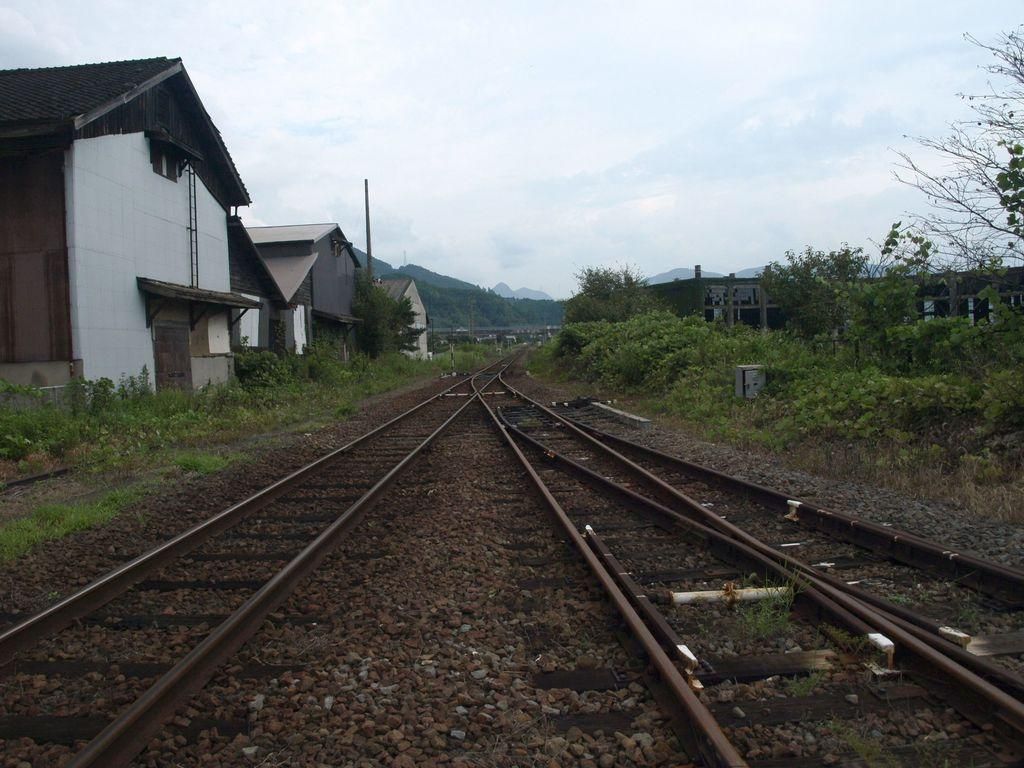What type of surface can be seen in the image? There are tracks in the image. What natural elements are present in the image? There are stones, plants, trees, and hills in the image. What man-made structures can be seen in the image? There are buildings in the image. Where is the notebook placed in the image? There is no notebook present in the image. What type of insect can be seen crawling on the plants in the image? There are no insects visible in the image; only plants, trees, and other elements are present. 